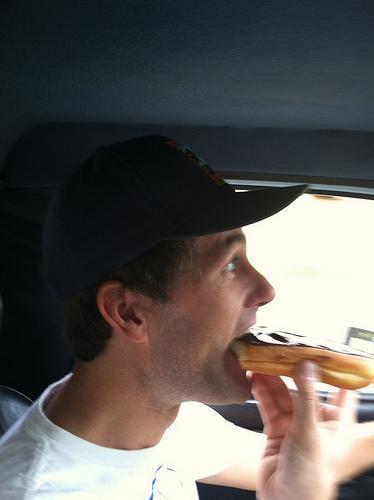How many people are in this picture?
Give a very brief answer. 1. 